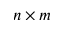<formula> <loc_0><loc_0><loc_500><loc_500>n \times m</formula> 